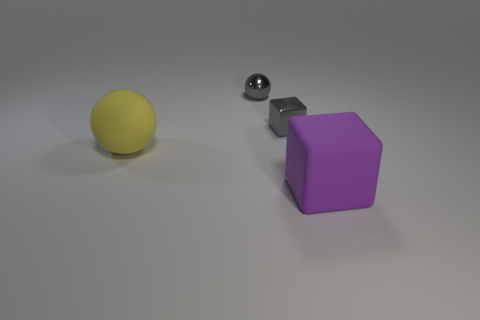Add 3 small gray metallic objects. How many objects exist? 7 Add 4 small gray metallic objects. How many small gray metallic objects exist? 6 Subtract 0 green cylinders. How many objects are left? 4 Subtract all gray cylinders. Subtract all gray cubes. How many objects are left? 3 Add 4 gray metallic spheres. How many gray metallic spheres are left? 5 